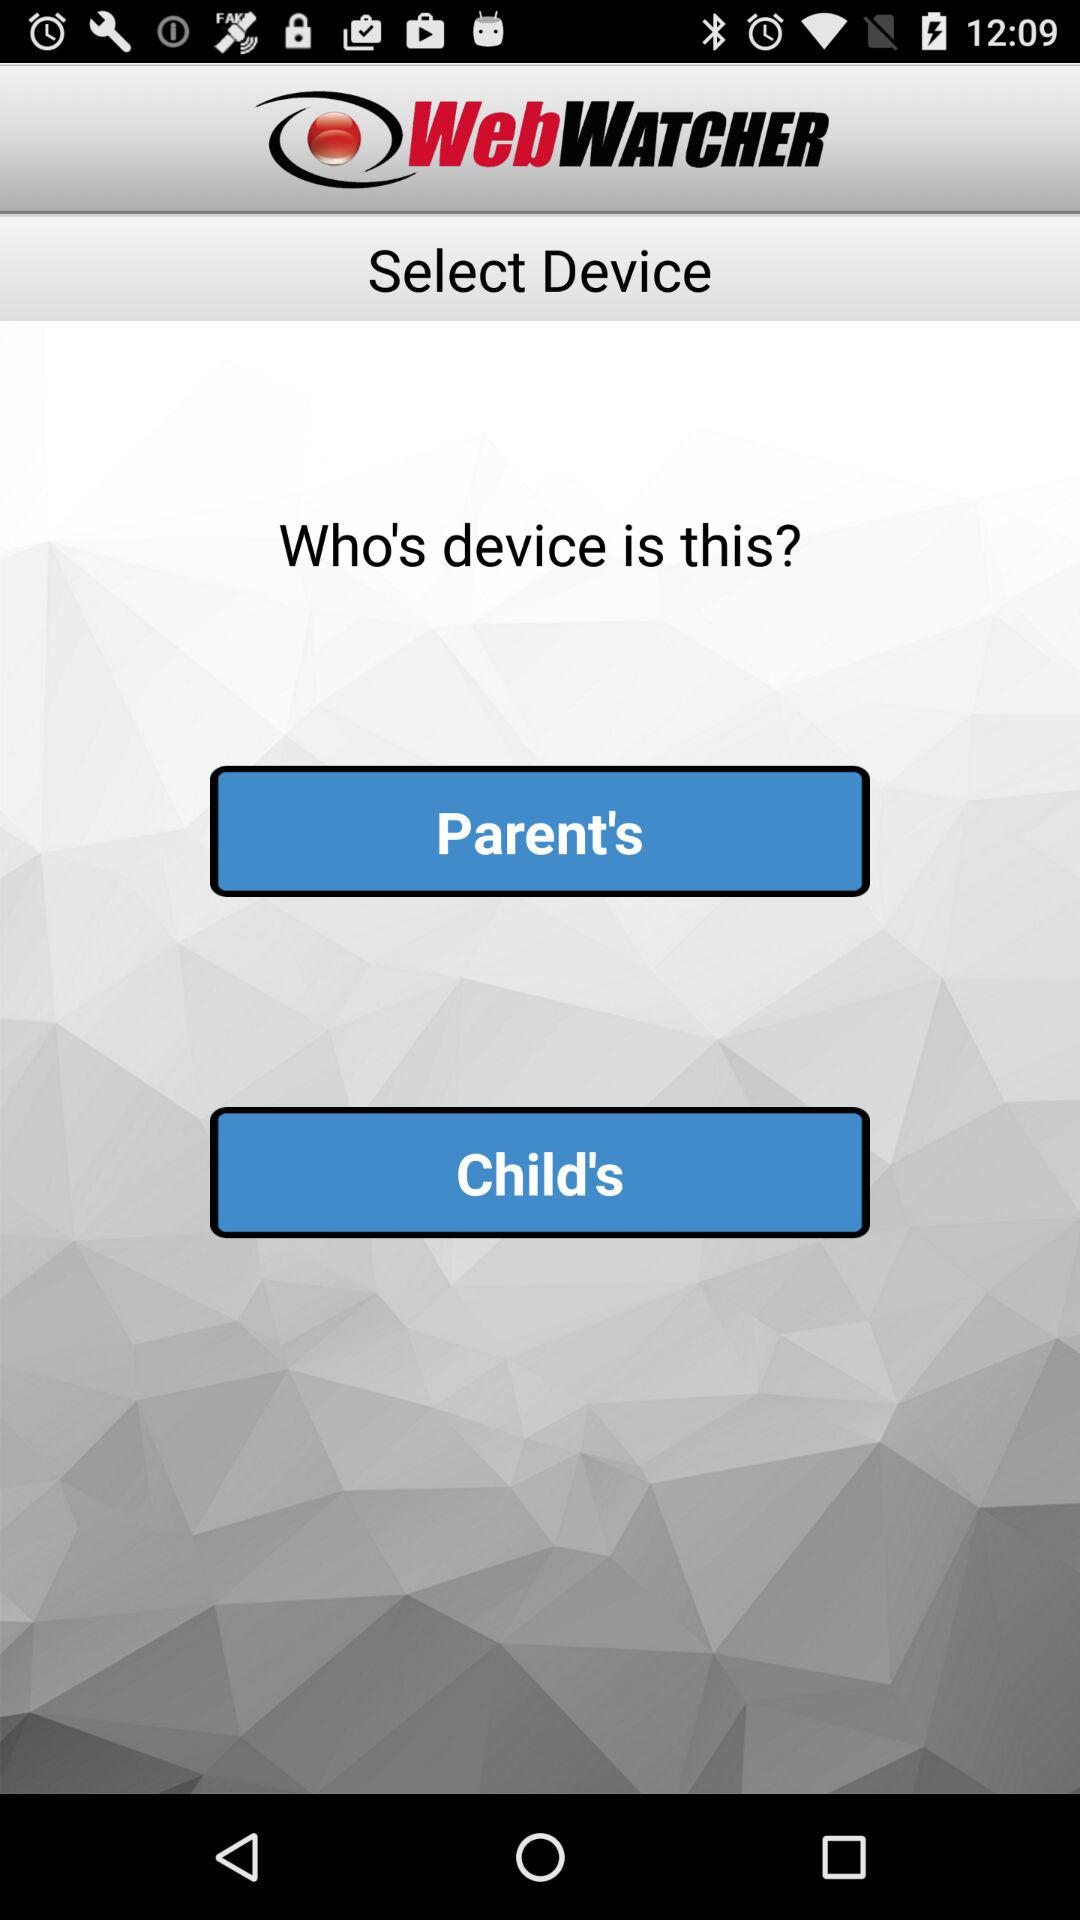What is the name of the application? The application name is "WebWATCHER". 